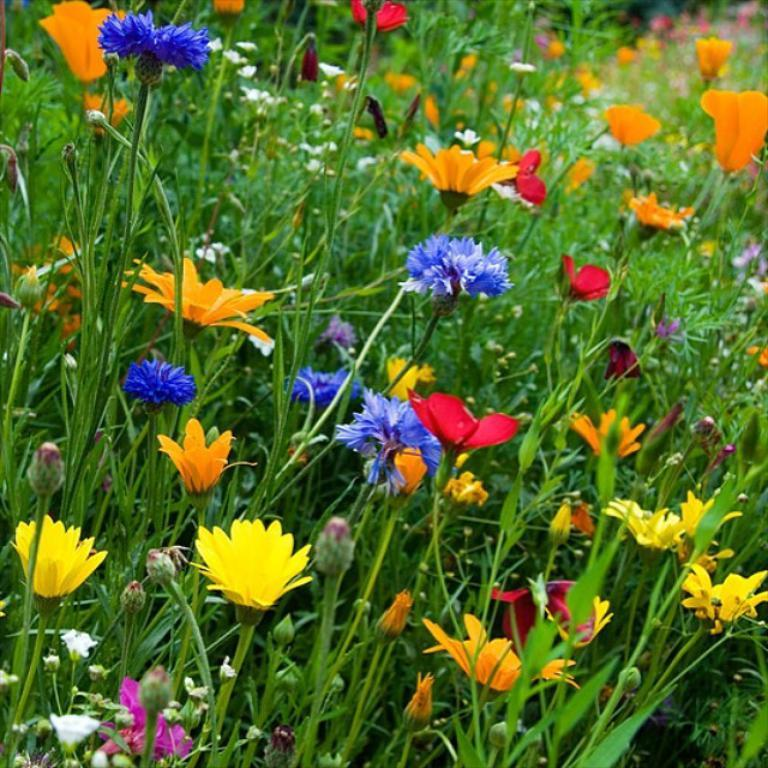What type of vegetation can be seen in the image? There are flowers, plants, and leaves in the image. Can you describe the specific elements of the vegetation? The flowers are colorful and appear to be in bloom, while the plants have stems and leaves. What can be inferred about the setting of the image? The presence of flowers, plants, and leaves suggests that the image was taken in a natural or garden setting. What type of lettuce can be seen in the image? There is no lettuce present in the image; it features flowers, plants, and leaves. How many balls are visible in the image? There are no balls present in the image. 